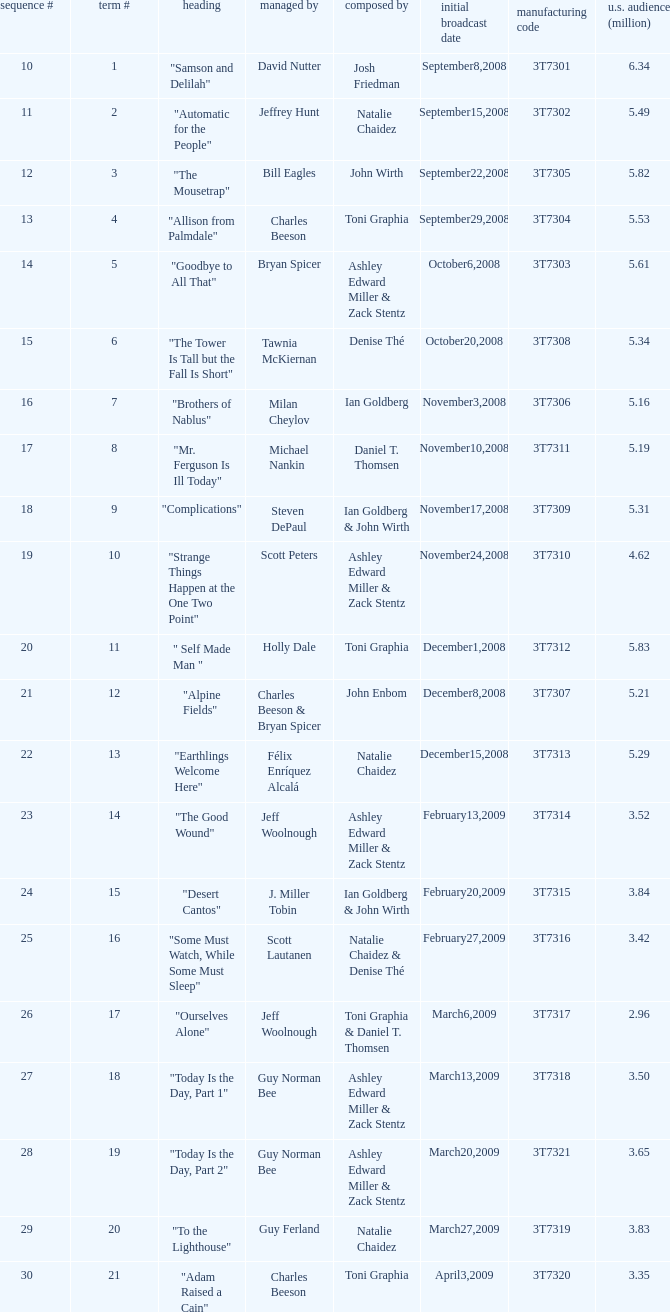Which episode number was directed by Bill Eagles? 12.0. 